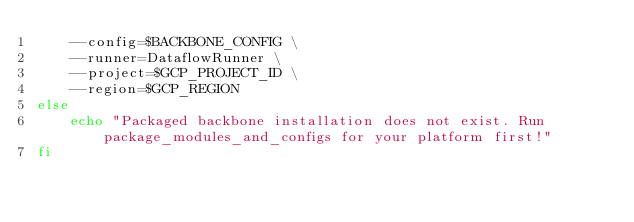<code> <loc_0><loc_0><loc_500><loc_500><_Bash_>    --config=$BACKBONE_CONFIG \
    --runner=DataflowRunner \
    --project=$GCP_PROJECT_ID \
    --region=$GCP_REGION
else
    echo "Packaged backbone installation does not exist. Run package_modules_and_configs for your platform first!"
fi
</code> 